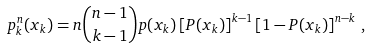Convert formula to latex. <formula><loc_0><loc_0><loc_500><loc_500>p ^ { n } _ { k } ( x _ { k } ) = n \binom { n - 1 } { k - 1 } p ( x _ { k } ) \left [ P ( x _ { k } ) \right ] ^ { k - 1 } \left [ 1 - P ( x _ { k } ) \right ] ^ { n - k } \, ,</formula> 